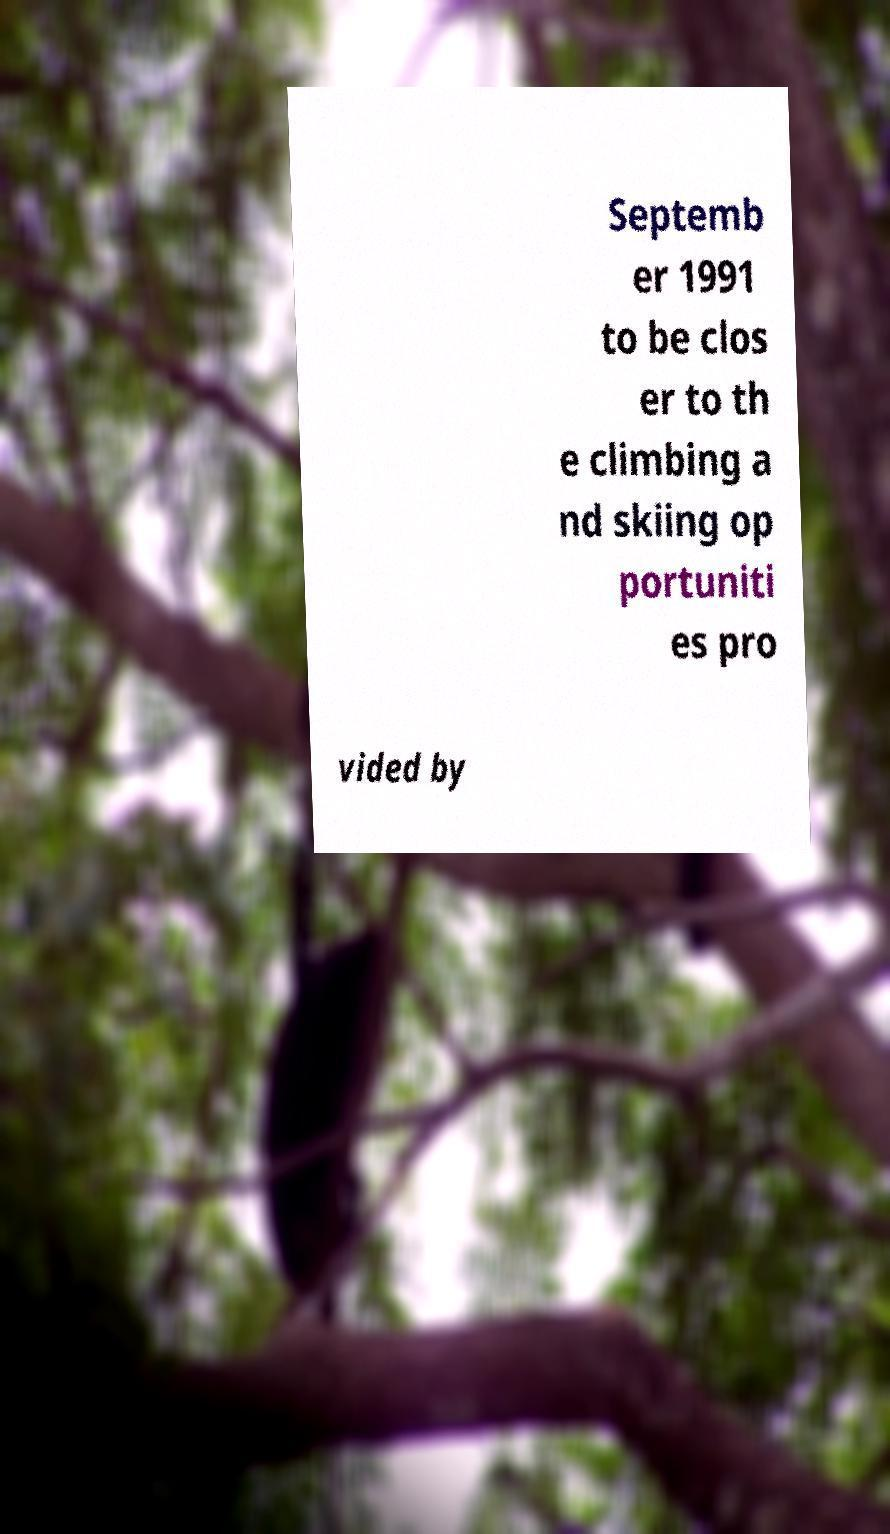Can you accurately transcribe the text from the provided image for me? Septemb er 1991 to be clos er to th e climbing a nd skiing op portuniti es pro vided by 